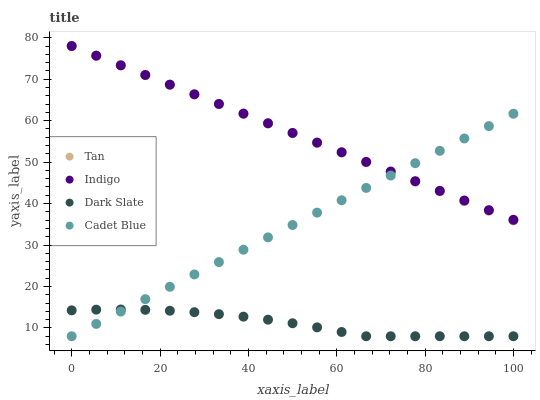Does Dark Slate have the minimum area under the curve?
Answer yes or no. Yes. Does Indigo have the maximum area under the curve?
Answer yes or no. Yes. Does Tan have the minimum area under the curve?
Answer yes or no. No. Does Tan have the maximum area under the curve?
Answer yes or no. No. Is Cadet Blue the smoothest?
Answer yes or no. Yes. Is Dark Slate the roughest?
Answer yes or no. Yes. Is Tan the smoothest?
Answer yes or no. No. Is Tan the roughest?
Answer yes or no. No. Does Dark Slate have the lowest value?
Answer yes or no. Yes. Does Tan have the lowest value?
Answer yes or no. No. Does Indigo have the highest value?
Answer yes or no. Yes. Does Cadet Blue have the highest value?
Answer yes or no. No. Is Dark Slate less than Tan?
Answer yes or no. Yes. Is Indigo greater than Dark Slate?
Answer yes or no. Yes. Does Dark Slate intersect Cadet Blue?
Answer yes or no. Yes. Is Dark Slate less than Cadet Blue?
Answer yes or no. No. Is Dark Slate greater than Cadet Blue?
Answer yes or no. No. Does Dark Slate intersect Tan?
Answer yes or no. No. 